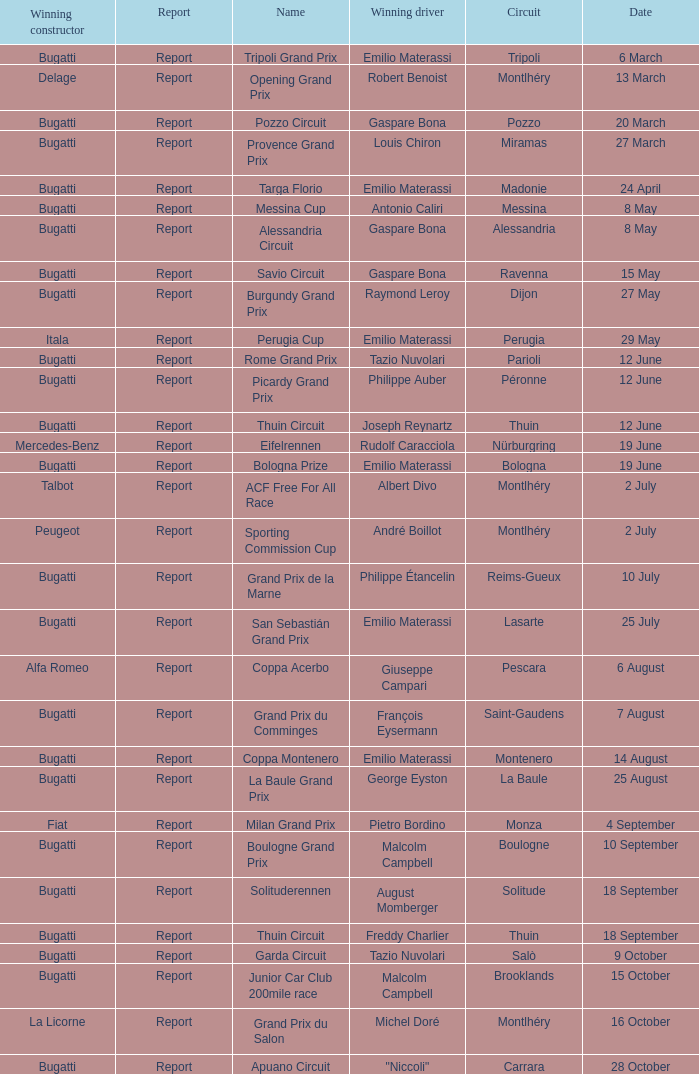When did Gaspare Bona win the Pozzo Circuit? 20 March. 